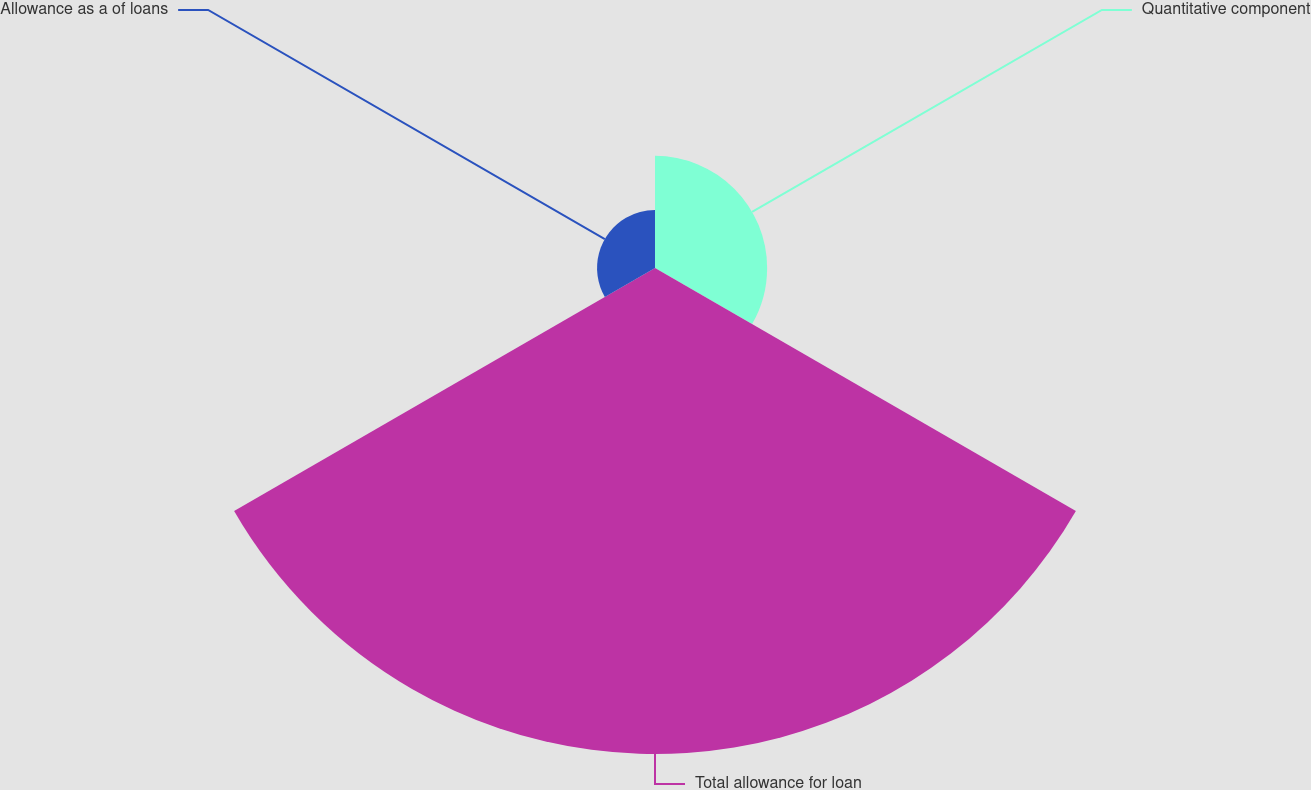Convert chart. <chart><loc_0><loc_0><loc_500><loc_500><pie_chart><fcel>Quantitative component<fcel>Total allowance for loan<fcel>Allowance as a of loans<nl><fcel>17.09%<fcel>74.07%<fcel>8.83%<nl></chart> 